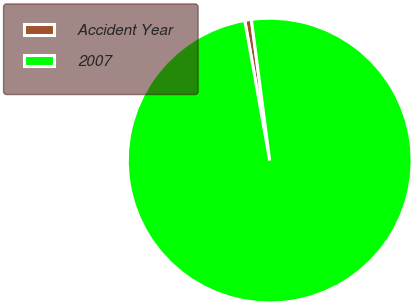Convert chart. <chart><loc_0><loc_0><loc_500><loc_500><pie_chart><fcel>Accident Year<fcel>2007<nl><fcel>0.75%<fcel>99.25%<nl></chart> 